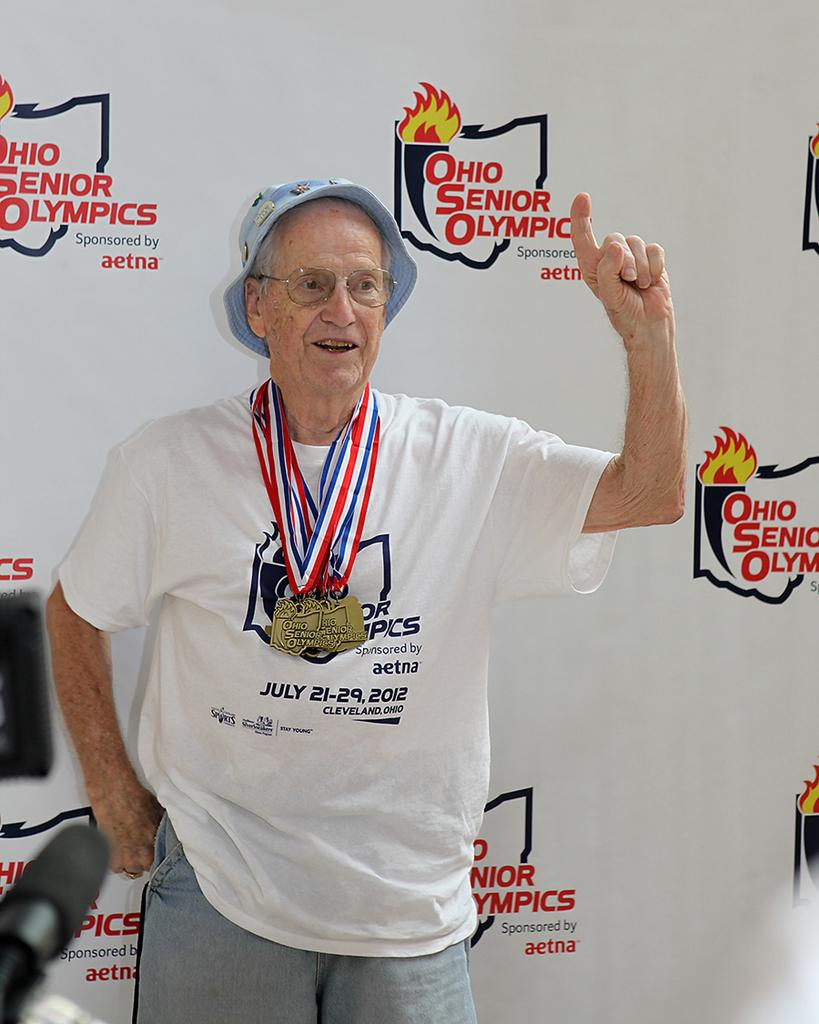<image>
Provide a brief description of the given image. Elderly wearing a shirt that says the date July 21 on it. 